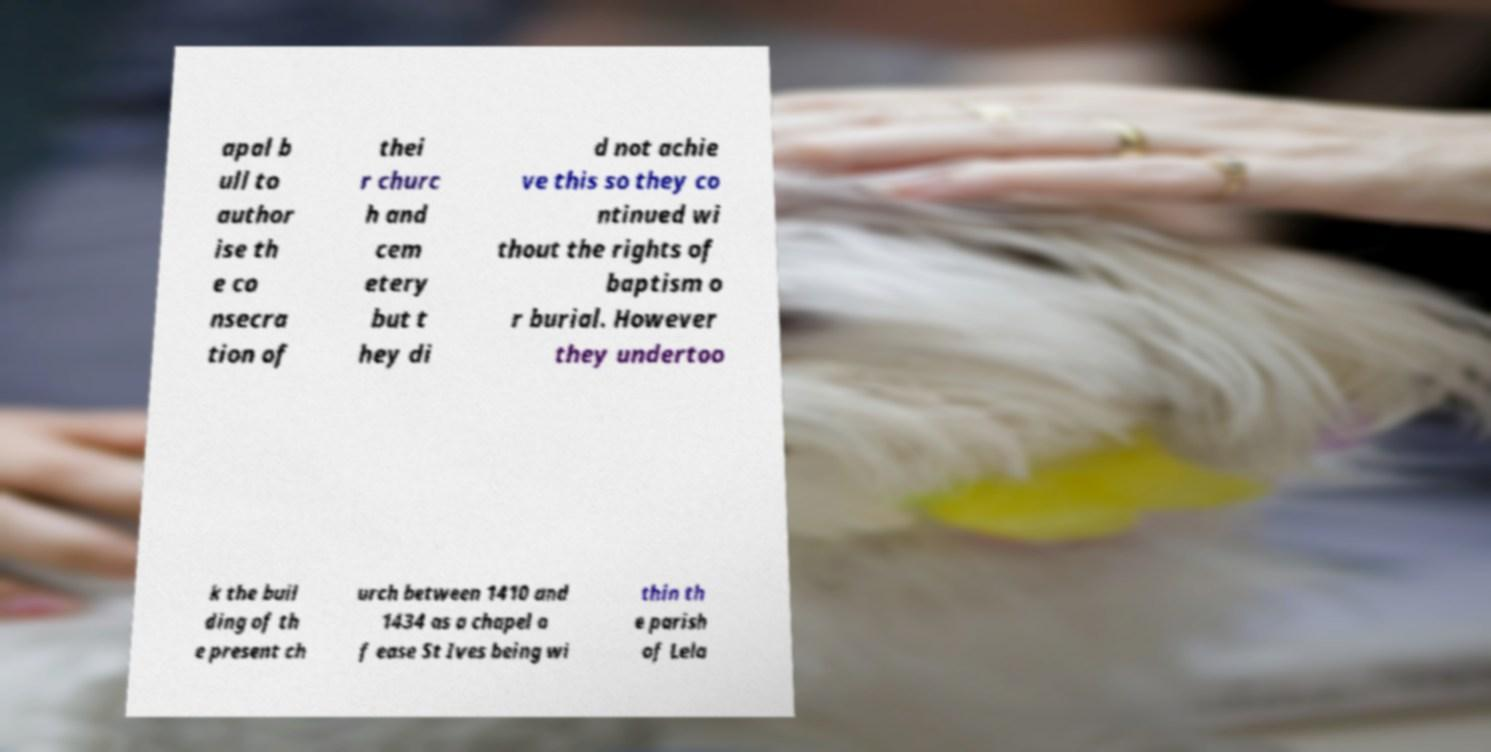Please read and relay the text visible in this image. What does it say? apal b ull to author ise th e co nsecra tion of thei r churc h and cem etery but t hey di d not achie ve this so they co ntinued wi thout the rights of baptism o r burial. However they undertoo k the buil ding of th e present ch urch between 1410 and 1434 as a chapel o f ease St Ives being wi thin th e parish of Lela 